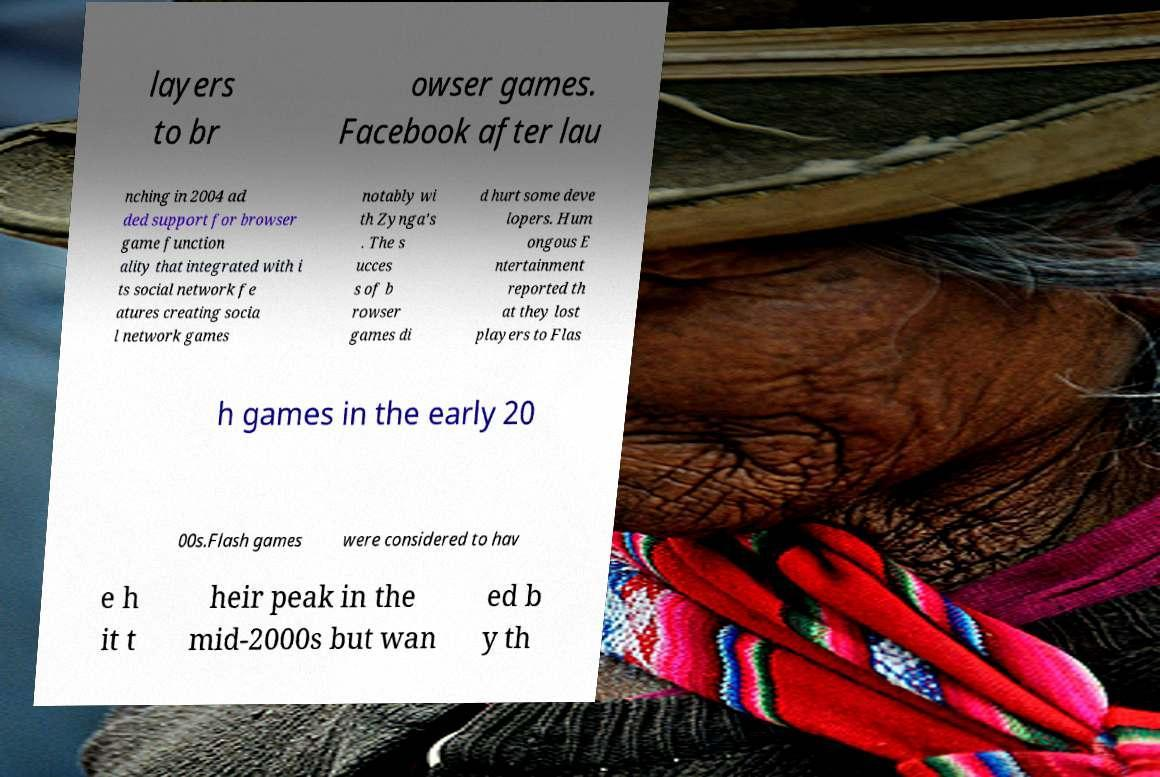I need the written content from this picture converted into text. Can you do that? layers to br owser games. Facebook after lau nching in 2004 ad ded support for browser game function ality that integrated with i ts social network fe atures creating socia l network games notably wi th Zynga's . The s ucces s of b rowser games di d hurt some deve lopers. Hum ongous E ntertainment reported th at they lost players to Flas h games in the early 20 00s.Flash games were considered to hav e h it t heir peak in the mid-2000s but wan ed b y th 